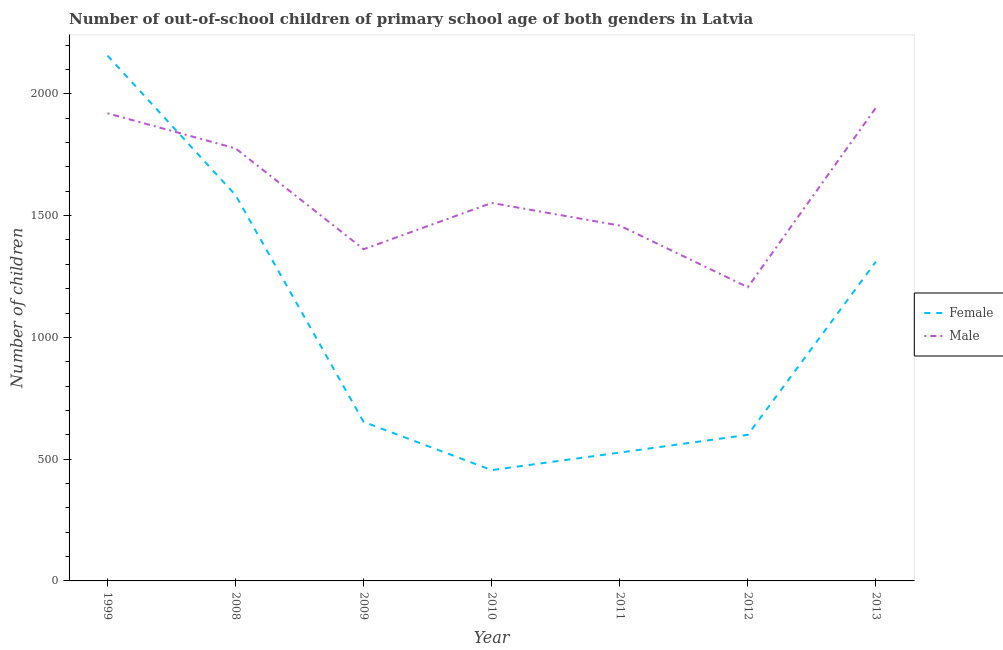How many different coloured lines are there?
Provide a succinct answer. 2. Does the line corresponding to number of female out-of-school students intersect with the line corresponding to number of male out-of-school students?
Your answer should be compact. Yes. What is the number of female out-of-school students in 2012?
Provide a short and direct response. 600. Across all years, what is the maximum number of male out-of-school students?
Make the answer very short. 1943. Across all years, what is the minimum number of female out-of-school students?
Make the answer very short. 455. In which year was the number of female out-of-school students maximum?
Offer a very short reply. 1999. In which year was the number of male out-of-school students minimum?
Your response must be concise. 2012. What is the total number of female out-of-school students in the graph?
Your answer should be very brief. 7287. What is the difference between the number of male out-of-school students in 2010 and that in 2013?
Offer a terse response. -391. What is the difference between the number of male out-of-school students in 1999 and the number of female out-of-school students in 2012?
Make the answer very short. 1320. What is the average number of female out-of-school students per year?
Your answer should be compact. 1041. In the year 2012, what is the difference between the number of male out-of-school students and number of female out-of-school students?
Offer a terse response. 606. What is the ratio of the number of female out-of-school students in 2008 to that in 2011?
Offer a very short reply. 3.01. Is the number of female out-of-school students in 2012 less than that in 2013?
Your answer should be very brief. Yes. What is the difference between the highest and the second highest number of female out-of-school students?
Make the answer very short. 573. What is the difference between the highest and the lowest number of male out-of-school students?
Offer a very short reply. 737. Is the sum of the number of male out-of-school students in 1999 and 2008 greater than the maximum number of female out-of-school students across all years?
Make the answer very short. Yes. Is the number of female out-of-school students strictly less than the number of male out-of-school students over the years?
Provide a succinct answer. No. Are the values on the major ticks of Y-axis written in scientific E-notation?
Your response must be concise. No. Does the graph contain any zero values?
Keep it short and to the point. No. How many legend labels are there?
Provide a short and direct response. 2. How are the legend labels stacked?
Provide a short and direct response. Vertical. What is the title of the graph?
Your answer should be compact. Number of out-of-school children of primary school age of both genders in Latvia. What is the label or title of the Y-axis?
Your answer should be compact. Number of children. What is the Number of children in Female in 1999?
Offer a terse response. 2157. What is the Number of children of Male in 1999?
Your answer should be compact. 1920. What is the Number of children in Female in 2008?
Your answer should be compact. 1584. What is the Number of children of Male in 2008?
Make the answer very short. 1776. What is the Number of children of Female in 2009?
Ensure brevity in your answer.  653. What is the Number of children in Male in 2009?
Offer a very short reply. 1362. What is the Number of children in Female in 2010?
Provide a succinct answer. 455. What is the Number of children in Male in 2010?
Your answer should be very brief. 1552. What is the Number of children of Female in 2011?
Keep it short and to the point. 527. What is the Number of children in Male in 2011?
Your answer should be compact. 1459. What is the Number of children of Female in 2012?
Offer a terse response. 600. What is the Number of children of Male in 2012?
Provide a succinct answer. 1206. What is the Number of children of Female in 2013?
Keep it short and to the point. 1311. What is the Number of children in Male in 2013?
Keep it short and to the point. 1943. Across all years, what is the maximum Number of children in Female?
Offer a terse response. 2157. Across all years, what is the maximum Number of children in Male?
Offer a terse response. 1943. Across all years, what is the minimum Number of children in Female?
Ensure brevity in your answer.  455. Across all years, what is the minimum Number of children of Male?
Ensure brevity in your answer.  1206. What is the total Number of children of Female in the graph?
Make the answer very short. 7287. What is the total Number of children in Male in the graph?
Your answer should be very brief. 1.12e+04. What is the difference between the Number of children in Female in 1999 and that in 2008?
Provide a short and direct response. 573. What is the difference between the Number of children of Male in 1999 and that in 2008?
Ensure brevity in your answer.  144. What is the difference between the Number of children of Female in 1999 and that in 2009?
Keep it short and to the point. 1504. What is the difference between the Number of children of Male in 1999 and that in 2009?
Provide a short and direct response. 558. What is the difference between the Number of children of Female in 1999 and that in 2010?
Give a very brief answer. 1702. What is the difference between the Number of children in Male in 1999 and that in 2010?
Your answer should be compact. 368. What is the difference between the Number of children of Female in 1999 and that in 2011?
Make the answer very short. 1630. What is the difference between the Number of children in Male in 1999 and that in 2011?
Provide a short and direct response. 461. What is the difference between the Number of children in Female in 1999 and that in 2012?
Your answer should be compact. 1557. What is the difference between the Number of children of Male in 1999 and that in 2012?
Give a very brief answer. 714. What is the difference between the Number of children in Female in 1999 and that in 2013?
Offer a terse response. 846. What is the difference between the Number of children of Female in 2008 and that in 2009?
Ensure brevity in your answer.  931. What is the difference between the Number of children in Male in 2008 and that in 2009?
Make the answer very short. 414. What is the difference between the Number of children in Female in 2008 and that in 2010?
Provide a succinct answer. 1129. What is the difference between the Number of children in Male in 2008 and that in 2010?
Your response must be concise. 224. What is the difference between the Number of children of Female in 2008 and that in 2011?
Your answer should be very brief. 1057. What is the difference between the Number of children in Male in 2008 and that in 2011?
Keep it short and to the point. 317. What is the difference between the Number of children in Female in 2008 and that in 2012?
Offer a very short reply. 984. What is the difference between the Number of children in Male in 2008 and that in 2012?
Provide a short and direct response. 570. What is the difference between the Number of children of Female in 2008 and that in 2013?
Make the answer very short. 273. What is the difference between the Number of children of Male in 2008 and that in 2013?
Give a very brief answer. -167. What is the difference between the Number of children in Female in 2009 and that in 2010?
Your answer should be compact. 198. What is the difference between the Number of children in Male in 2009 and that in 2010?
Ensure brevity in your answer.  -190. What is the difference between the Number of children in Female in 2009 and that in 2011?
Keep it short and to the point. 126. What is the difference between the Number of children in Male in 2009 and that in 2011?
Keep it short and to the point. -97. What is the difference between the Number of children of Male in 2009 and that in 2012?
Your response must be concise. 156. What is the difference between the Number of children in Female in 2009 and that in 2013?
Make the answer very short. -658. What is the difference between the Number of children of Male in 2009 and that in 2013?
Offer a very short reply. -581. What is the difference between the Number of children in Female in 2010 and that in 2011?
Provide a succinct answer. -72. What is the difference between the Number of children of Male in 2010 and that in 2011?
Provide a short and direct response. 93. What is the difference between the Number of children of Female in 2010 and that in 2012?
Offer a very short reply. -145. What is the difference between the Number of children of Male in 2010 and that in 2012?
Your answer should be compact. 346. What is the difference between the Number of children in Female in 2010 and that in 2013?
Your response must be concise. -856. What is the difference between the Number of children in Male in 2010 and that in 2013?
Your answer should be compact. -391. What is the difference between the Number of children in Female in 2011 and that in 2012?
Provide a short and direct response. -73. What is the difference between the Number of children of Male in 2011 and that in 2012?
Your answer should be compact. 253. What is the difference between the Number of children in Female in 2011 and that in 2013?
Provide a short and direct response. -784. What is the difference between the Number of children in Male in 2011 and that in 2013?
Offer a terse response. -484. What is the difference between the Number of children in Female in 2012 and that in 2013?
Provide a succinct answer. -711. What is the difference between the Number of children in Male in 2012 and that in 2013?
Give a very brief answer. -737. What is the difference between the Number of children in Female in 1999 and the Number of children in Male in 2008?
Keep it short and to the point. 381. What is the difference between the Number of children of Female in 1999 and the Number of children of Male in 2009?
Make the answer very short. 795. What is the difference between the Number of children in Female in 1999 and the Number of children in Male in 2010?
Your answer should be compact. 605. What is the difference between the Number of children in Female in 1999 and the Number of children in Male in 2011?
Offer a terse response. 698. What is the difference between the Number of children of Female in 1999 and the Number of children of Male in 2012?
Offer a terse response. 951. What is the difference between the Number of children of Female in 1999 and the Number of children of Male in 2013?
Give a very brief answer. 214. What is the difference between the Number of children of Female in 2008 and the Number of children of Male in 2009?
Provide a succinct answer. 222. What is the difference between the Number of children in Female in 2008 and the Number of children in Male in 2010?
Offer a terse response. 32. What is the difference between the Number of children in Female in 2008 and the Number of children in Male in 2011?
Offer a terse response. 125. What is the difference between the Number of children of Female in 2008 and the Number of children of Male in 2012?
Provide a succinct answer. 378. What is the difference between the Number of children of Female in 2008 and the Number of children of Male in 2013?
Make the answer very short. -359. What is the difference between the Number of children of Female in 2009 and the Number of children of Male in 2010?
Provide a succinct answer. -899. What is the difference between the Number of children in Female in 2009 and the Number of children in Male in 2011?
Offer a terse response. -806. What is the difference between the Number of children of Female in 2009 and the Number of children of Male in 2012?
Make the answer very short. -553. What is the difference between the Number of children in Female in 2009 and the Number of children in Male in 2013?
Offer a very short reply. -1290. What is the difference between the Number of children in Female in 2010 and the Number of children in Male in 2011?
Make the answer very short. -1004. What is the difference between the Number of children of Female in 2010 and the Number of children of Male in 2012?
Give a very brief answer. -751. What is the difference between the Number of children in Female in 2010 and the Number of children in Male in 2013?
Your answer should be very brief. -1488. What is the difference between the Number of children in Female in 2011 and the Number of children in Male in 2012?
Provide a succinct answer. -679. What is the difference between the Number of children of Female in 2011 and the Number of children of Male in 2013?
Your answer should be very brief. -1416. What is the difference between the Number of children of Female in 2012 and the Number of children of Male in 2013?
Provide a short and direct response. -1343. What is the average Number of children of Female per year?
Offer a very short reply. 1041. What is the average Number of children in Male per year?
Keep it short and to the point. 1602.57. In the year 1999, what is the difference between the Number of children of Female and Number of children of Male?
Make the answer very short. 237. In the year 2008, what is the difference between the Number of children of Female and Number of children of Male?
Make the answer very short. -192. In the year 2009, what is the difference between the Number of children of Female and Number of children of Male?
Keep it short and to the point. -709. In the year 2010, what is the difference between the Number of children of Female and Number of children of Male?
Offer a very short reply. -1097. In the year 2011, what is the difference between the Number of children in Female and Number of children in Male?
Your answer should be very brief. -932. In the year 2012, what is the difference between the Number of children in Female and Number of children in Male?
Make the answer very short. -606. In the year 2013, what is the difference between the Number of children in Female and Number of children in Male?
Provide a short and direct response. -632. What is the ratio of the Number of children in Female in 1999 to that in 2008?
Your response must be concise. 1.36. What is the ratio of the Number of children of Male in 1999 to that in 2008?
Your answer should be very brief. 1.08. What is the ratio of the Number of children of Female in 1999 to that in 2009?
Ensure brevity in your answer.  3.3. What is the ratio of the Number of children in Male in 1999 to that in 2009?
Your answer should be very brief. 1.41. What is the ratio of the Number of children of Female in 1999 to that in 2010?
Your response must be concise. 4.74. What is the ratio of the Number of children of Male in 1999 to that in 2010?
Your answer should be compact. 1.24. What is the ratio of the Number of children in Female in 1999 to that in 2011?
Make the answer very short. 4.09. What is the ratio of the Number of children in Male in 1999 to that in 2011?
Keep it short and to the point. 1.32. What is the ratio of the Number of children in Female in 1999 to that in 2012?
Offer a very short reply. 3.6. What is the ratio of the Number of children in Male in 1999 to that in 2012?
Give a very brief answer. 1.59. What is the ratio of the Number of children in Female in 1999 to that in 2013?
Give a very brief answer. 1.65. What is the ratio of the Number of children of Male in 1999 to that in 2013?
Provide a succinct answer. 0.99. What is the ratio of the Number of children of Female in 2008 to that in 2009?
Your answer should be compact. 2.43. What is the ratio of the Number of children in Male in 2008 to that in 2009?
Provide a short and direct response. 1.3. What is the ratio of the Number of children in Female in 2008 to that in 2010?
Give a very brief answer. 3.48. What is the ratio of the Number of children of Male in 2008 to that in 2010?
Your answer should be compact. 1.14. What is the ratio of the Number of children of Female in 2008 to that in 2011?
Ensure brevity in your answer.  3.01. What is the ratio of the Number of children of Male in 2008 to that in 2011?
Make the answer very short. 1.22. What is the ratio of the Number of children in Female in 2008 to that in 2012?
Ensure brevity in your answer.  2.64. What is the ratio of the Number of children of Male in 2008 to that in 2012?
Make the answer very short. 1.47. What is the ratio of the Number of children in Female in 2008 to that in 2013?
Provide a short and direct response. 1.21. What is the ratio of the Number of children of Male in 2008 to that in 2013?
Your answer should be compact. 0.91. What is the ratio of the Number of children of Female in 2009 to that in 2010?
Give a very brief answer. 1.44. What is the ratio of the Number of children in Male in 2009 to that in 2010?
Your response must be concise. 0.88. What is the ratio of the Number of children of Female in 2009 to that in 2011?
Offer a terse response. 1.24. What is the ratio of the Number of children of Male in 2009 to that in 2011?
Provide a short and direct response. 0.93. What is the ratio of the Number of children in Female in 2009 to that in 2012?
Provide a short and direct response. 1.09. What is the ratio of the Number of children in Male in 2009 to that in 2012?
Keep it short and to the point. 1.13. What is the ratio of the Number of children of Female in 2009 to that in 2013?
Your answer should be very brief. 0.5. What is the ratio of the Number of children of Male in 2009 to that in 2013?
Keep it short and to the point. 0.7. What is the ratio of the Number of children in Female in 2010 to that in 2011?
Ensure brevity in your answer.  0.86. What is the ratio of the Number of children of Male in 2010 to that in 2011?
Your answer should be very brief. 1.06. What is the ratio of the Number of children of Female in 2010 to that in 2012?
Keep it short and to the point. 0.76. What is the ratio of the Number of children of Male in 2010 to that in 2012?
Keep it short and to the point. 1.29. What is the ratio of the Number of children of Female in 2010 to that in 2013?
Ensure brevity in your answer.  0.35. What is the ratio of the Number of children in Male in 2010 to that in 2013?
Provide a succinct answer. 0.8. What is the ratio of the Number of children of Female in 2011 to that in 2012?
Provide a short and direct response. 0.88. What is the ratio of the Number of children in Male in 2011 to that in 2012?
Provide a short and direct response. 1.21. What is the ratio of the Number of children in Female in 2011 to that in 2013?
Give a very brief answer. 0.4. What is the ratio of the Number of children of Male in 2011 to that in 2013?
Your answer should be very brief. 0.75. What is the ratio of the Number of children in Female in 2012 to that in 2013?
Offer a terse response. 0.46. What is the ratio of the Number of children in Male in 2012 to that in 2013?
Keep it short and to the point. 0.62. What is the difference between the highest and the second highest Number of children in Female?
Your answer should be very brief. 573. What is the difference between the highest and the second highest Number of children in Male?
Keep it short and to the point. 23. What is the difference between the highest and the lowest Number of children of Female?
Provide a succinct answer. 1702. What is the difference between the highest and the lowest Number of children in Male?
Make the answer very short. 737. 